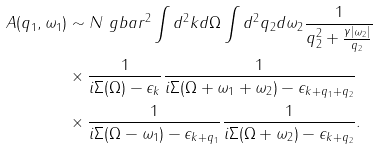<formula> <loc_0><loc_0><loc_500><loc_500>A ( q _ { 1 } , \omega _ { 1 } ) & \sim N \ g b a r ^ { 2 } \int d ^ { 2 } k d \Omega \int d ^ { 2 } q _ { 2 } d \omega _ { 2 } \frac { 1 } { q _ { 2 } ^ { 2 } + \frac { \gamma | \omega _ { 2 } | } { q _ { 2 } } } \\ & \times \frac { 1 } { i \Sigma ( \Omega ) - \epsilon _ { k } } \frac { 1 } { i \Sigma ( \Omega + \omega _ { 1 } + \omega _ { 2 } ) - \epsilon _ { k + q _ { 1 } + q _ { 2 } } } \\ & \times \frac { 1 } { i \Sigma ( \Omega - \omega _ { 1 } ) - \epsilon _ { k + q _ { 1 } } } \frac { 1 } { i \Sigma ( \Omega + \omega _ { 2 } ) - \epsilon _ { k + q _ { 2 } } } .</formula> 